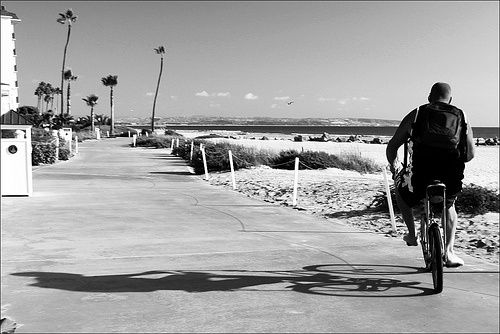Describe the objects in this image and their specific colors. I can see people in black, gray, lightgray, and darkgray tones, bicycle in black, gray, darkgray, and lightgray tones, backpack in black and gray tones, handbag in black, gray, and lightgray tones, and bird in gray, darkgray, lightgray, and black tones in this image. 